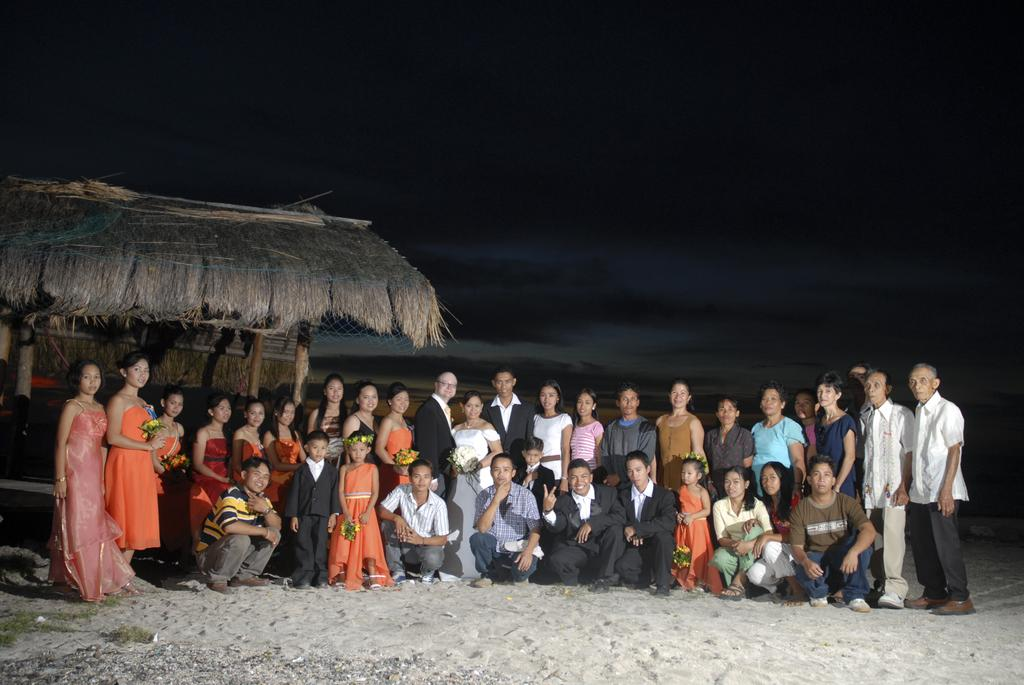How many people are in the image? There is a group of people in the image, but the exact number cannot be determined from the provided facts. What is located in the background of the image? There appears to be a hut in the background of the image. What is visible in the sky in the image? The sky is visible in the image, but no specific details about the sky are provided. How many kittens are being distributed by the stranger in the image? There is no mention of kittens or a stranger in the image, so this question cannot be answered. 